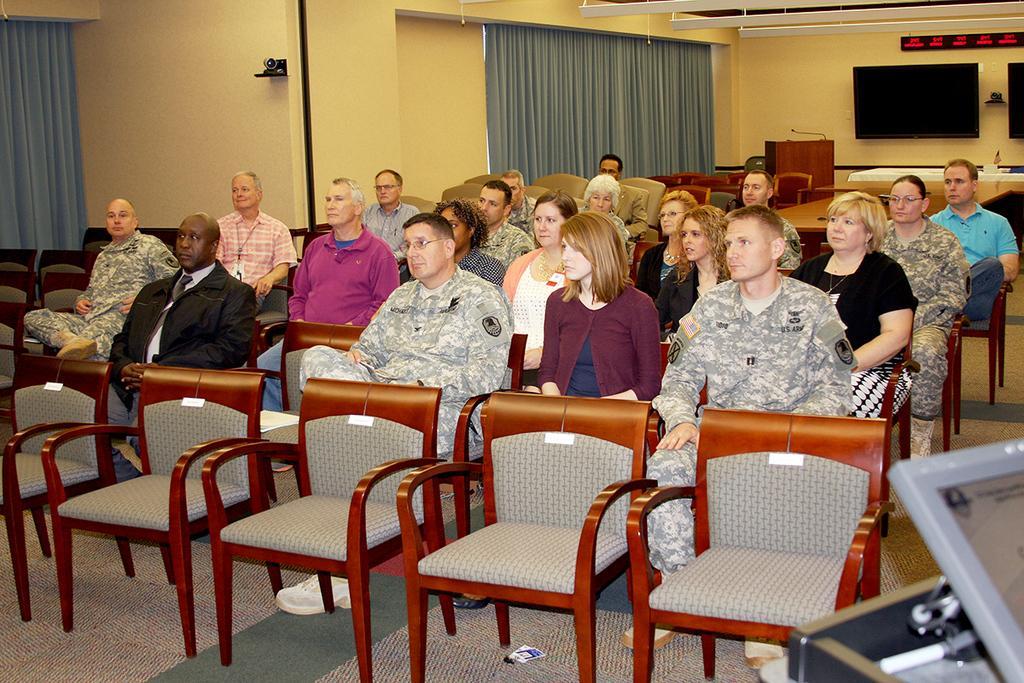In one or two sentences, can you explain what this image depicts? In this image there are a group a of people who are sitting on a chairs. On the background there is a wall and curtains are there and on the top of the right corner there is a television. 